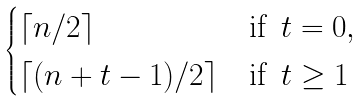Convert formula to latex. <formula><loc_0><loc_0><loc_500><loc_500>\begin{cases} \lceil n / 2 \rceil & \text {if } \, t = 0 , \\ \lceil ( n + t - 1 ) / 2 \rceil & \text {if } \, t \geq 1 \end{cases}</formula> 